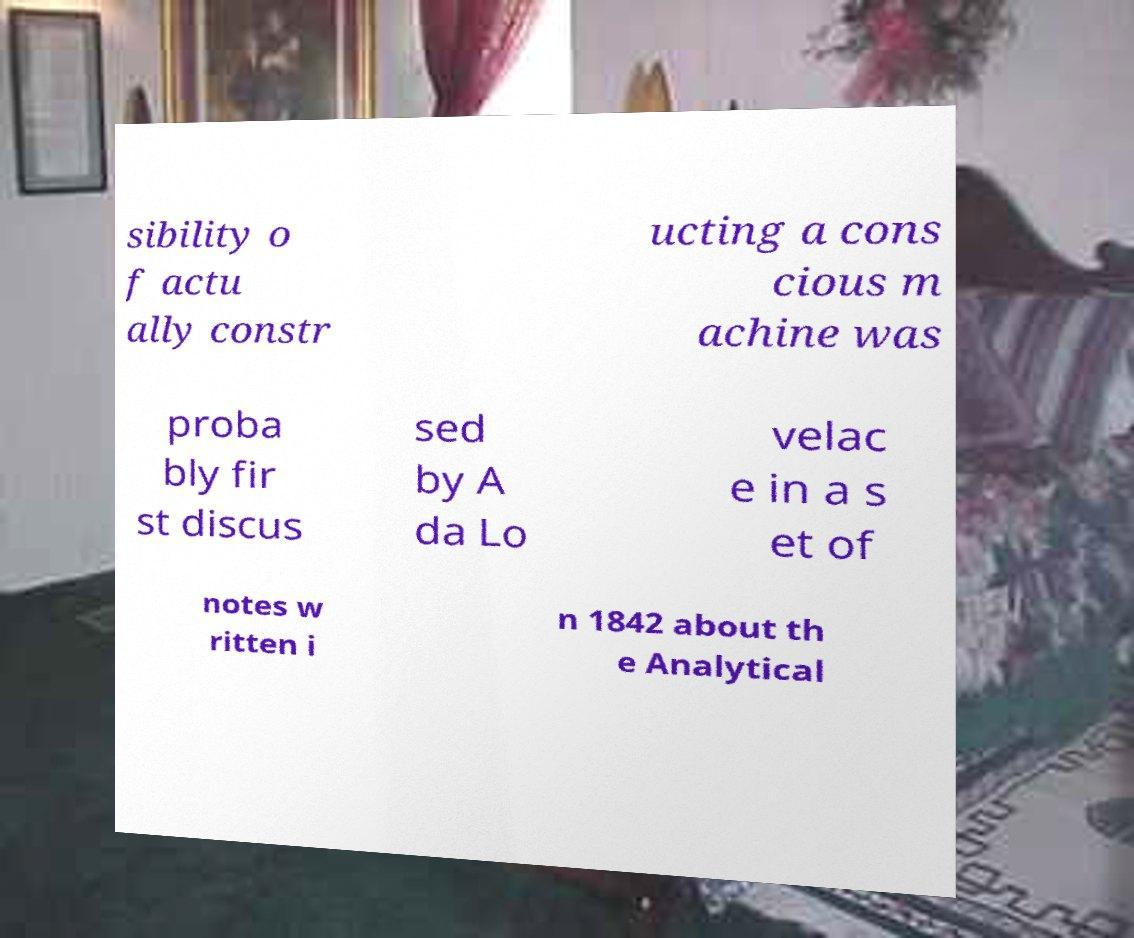What messages or text are displayed in this image? I need them in a readable, typed format. sibility o f actu ally constr ucting a cons cious m achine was proba bly fir st discus sed by A da Lo velac e in a s et of notes w ritten i n 1842 about th e Analytical 